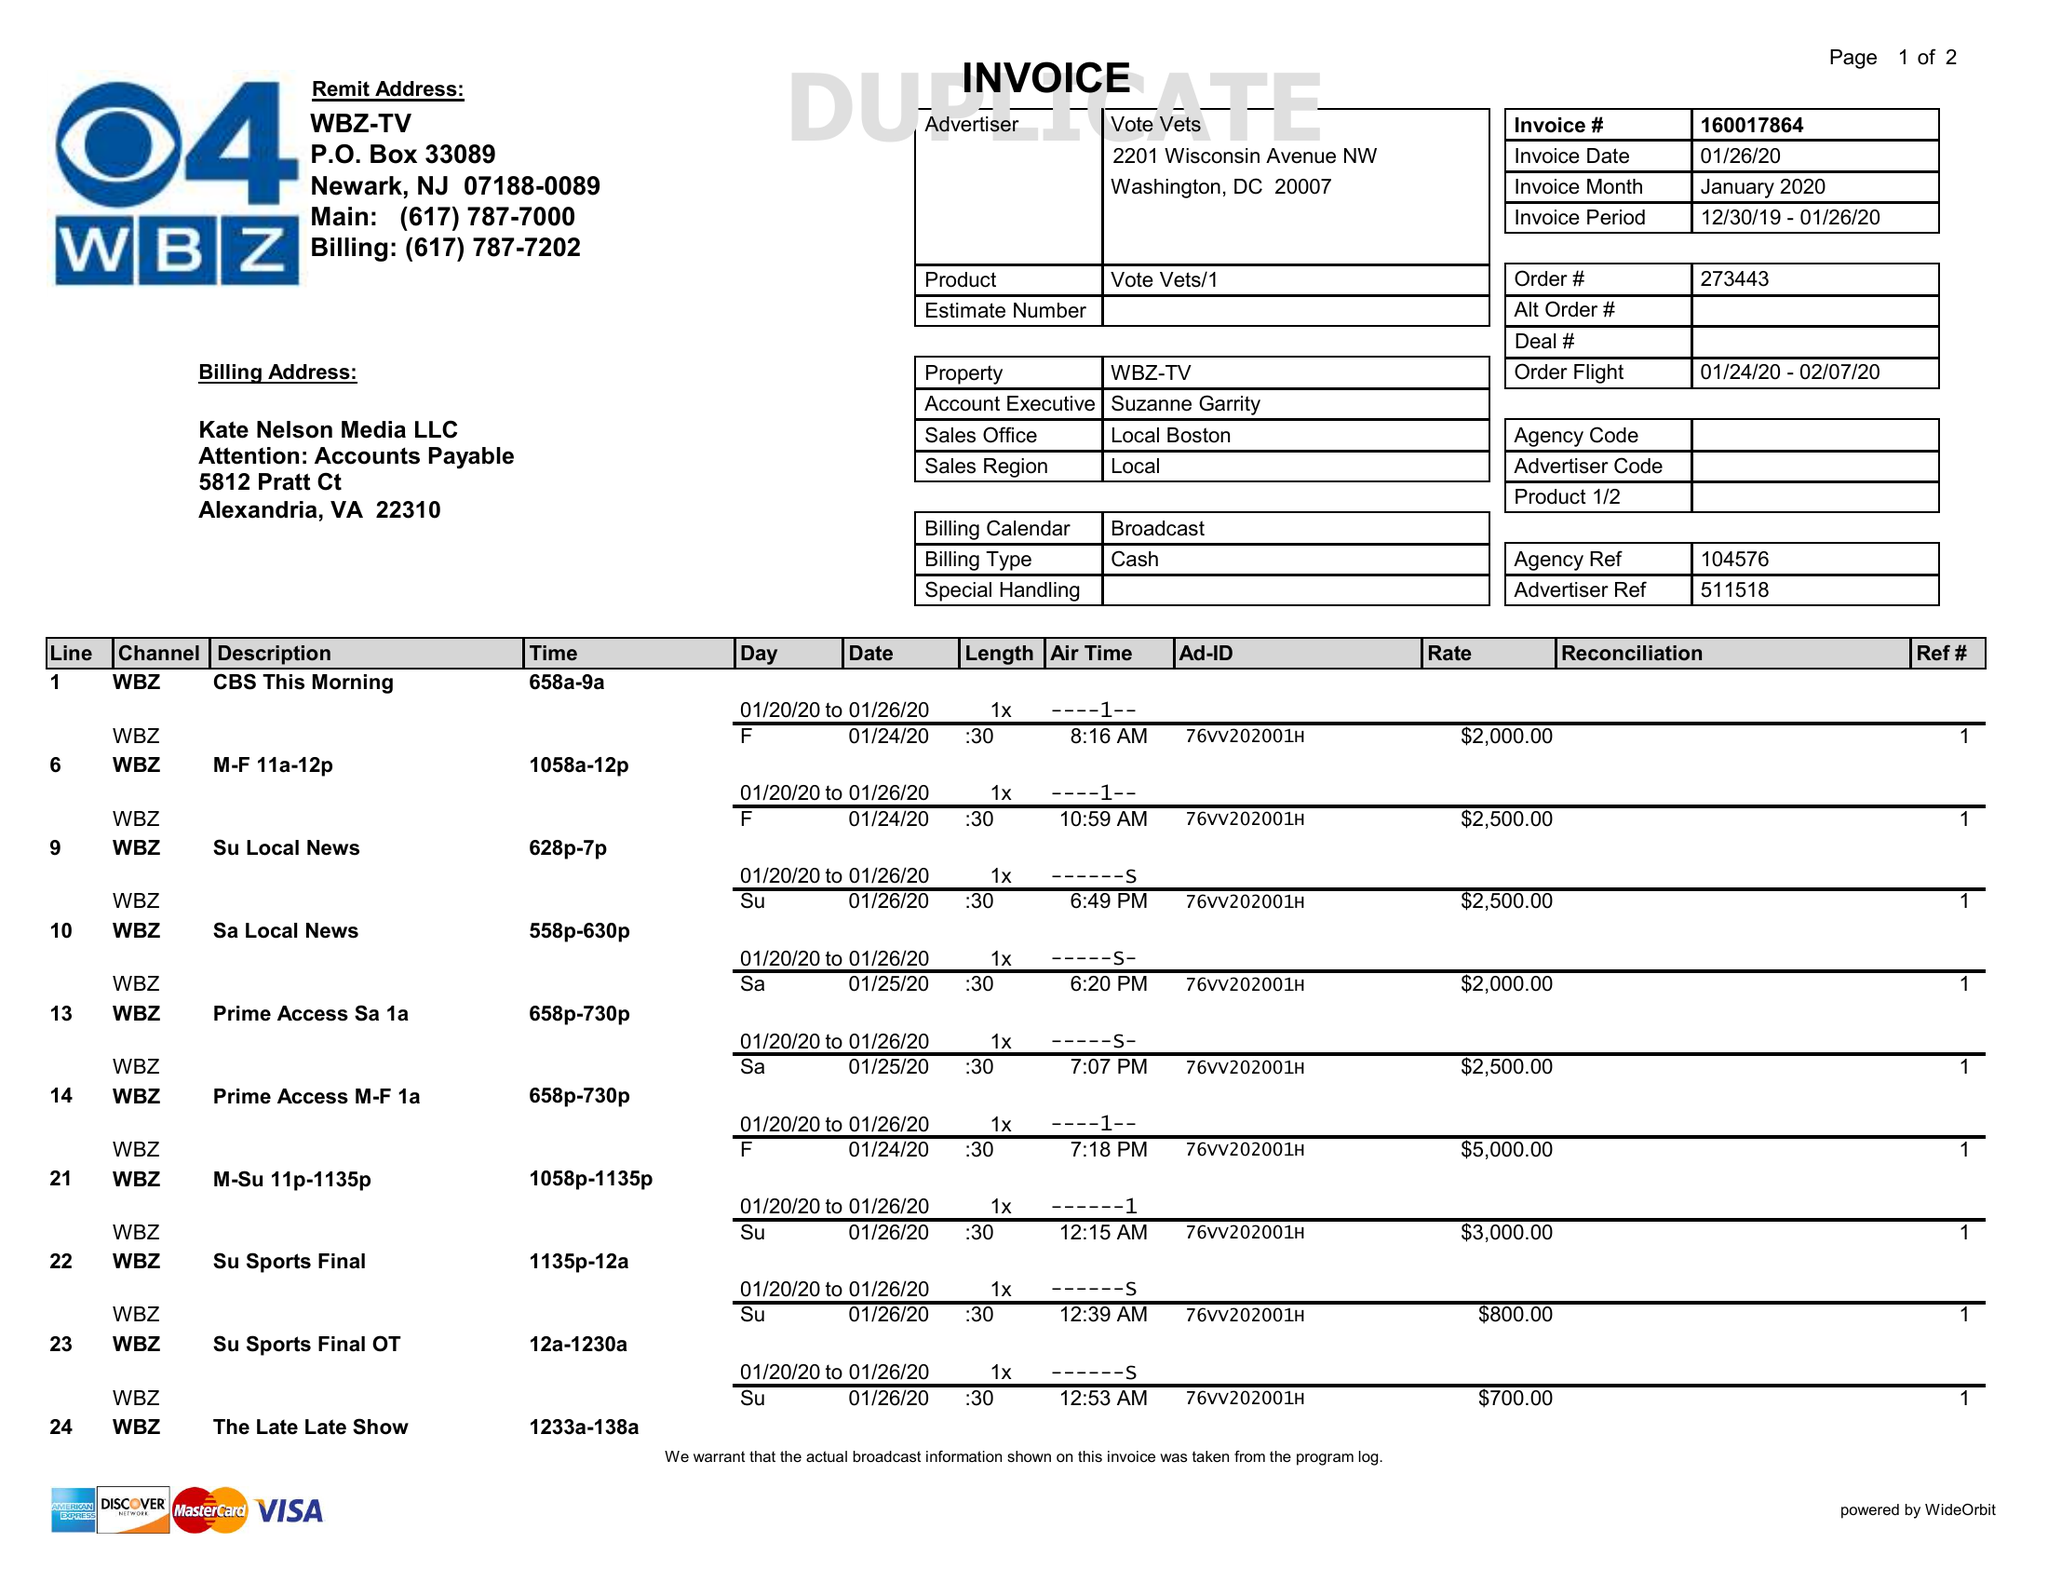What is the value for the flight_from?
Answer the question using a single word or phrase. 01/24/20 